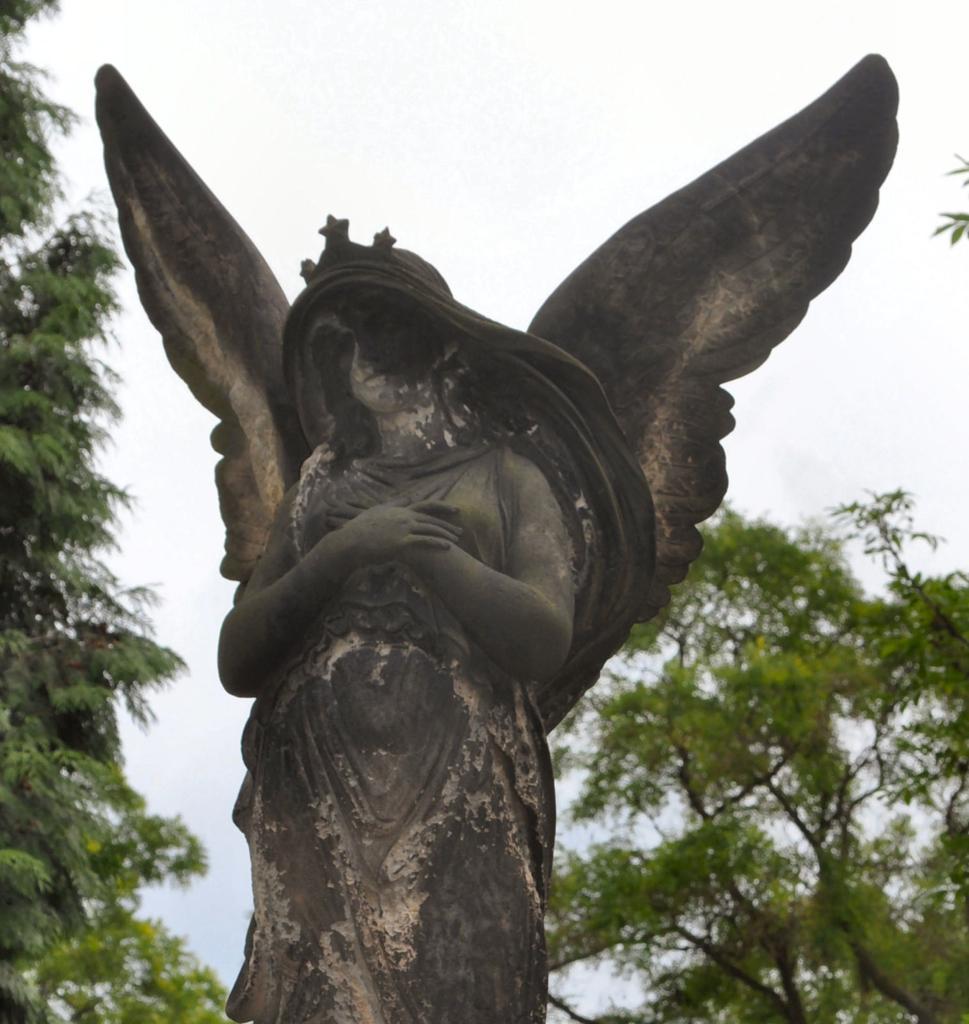In one or two sentences, can you explain what this image depicts? In this image in the foreground there is one statue and in the background there are some trees and sky. 